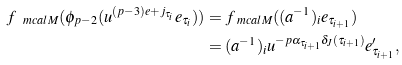<formula> <loc_0><loc_0><loc_500><loc_500>f _ { \ m c a l { M } } ( \phi _ { p - 2 } ( u ^ { ( p - 3 ) e + j _ { \tau _ { i } } } e _ { \tau _ { i } } ) ) & = f _ { \ m c a l { M } } ( ( a ^ { - 1 } ) _ { i } e _ { \tau _ { i + 1 } } ) \\ & = ( a ^ { - 1 } ) _ { i } u ^ { - p \alpha _ { \tau _ { i + 1 } } \delta _ { J } ( \tau _ { i + 1 } ) } e ^ { \prime } _ { \tau _ { i + 1 } } ,</formula> 